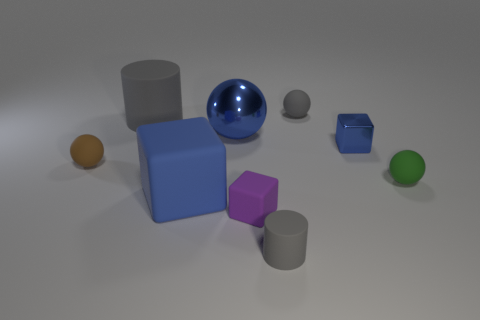Subtract all blue spheres. How many spheres are left? 3 Subtract 3 blocks. How many blocks are left? 0 Add 1 big cylinders. How many objects exist? 10 Subtract all blue blocks. How many blocks are left? 1 Subtract all spheres. How many objects are left? 5 Subtract all red cubes. Subtract all cyan cylinders. How many cubes are left? 3 Subtract all gray cubes. How many yellow cylinders are left? 0 Subtract all blocks. Subtract all blocks. How many objects are left? 3 Add 4 tiny brown matte spheres. How many tiny brown matte spheres are left? 5 Add 9 blue shiny spheres. How many blue shiny spheres exist? 10 